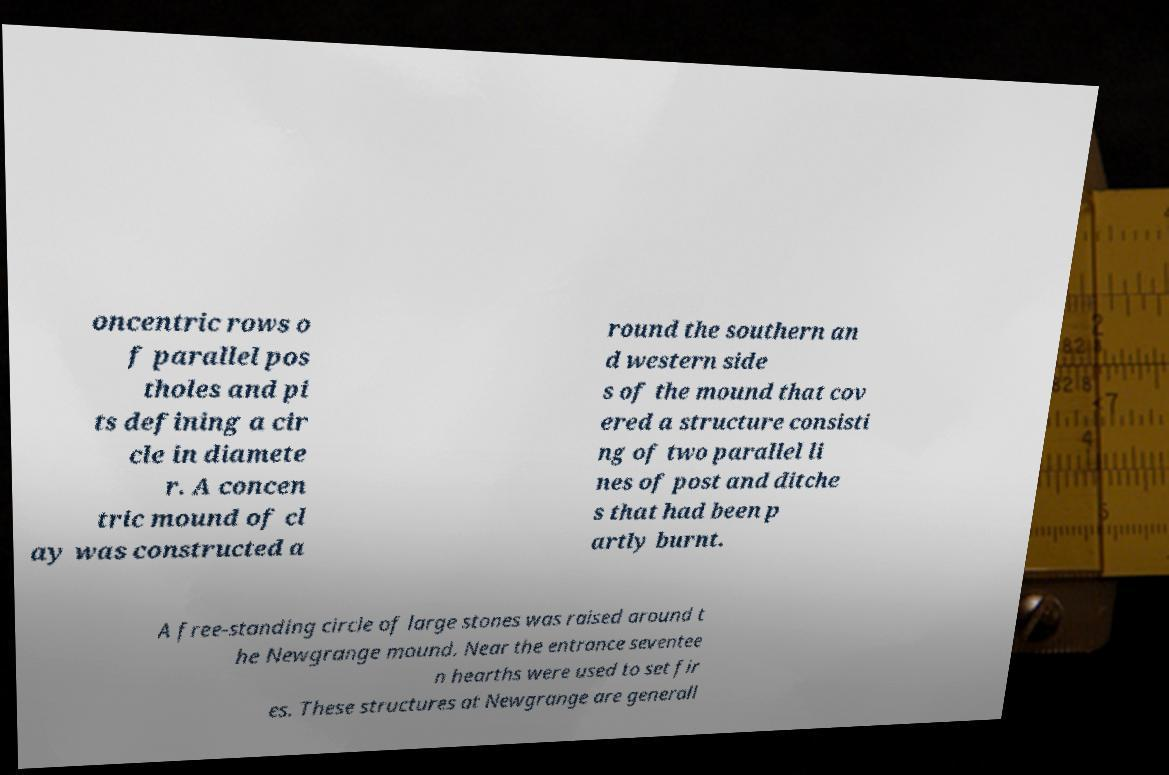Could you assist in decoding the text presented in this image and type it out clearly? oncentric rows o f parallel pos tholes and pi ts defining a cir cle in diamete r. A concen tric mound of cl ay was constructed a round the southern an d western side s of the mound that cov ered a structure consisti ng of two parallel li nes of post and ditche s that had been p artly burnt. A free-standing circle of large stones was raised around t he Newgrange mound. Near the entrance seventee n hearths were used to set fir es. These structures at Newgrange are generall 